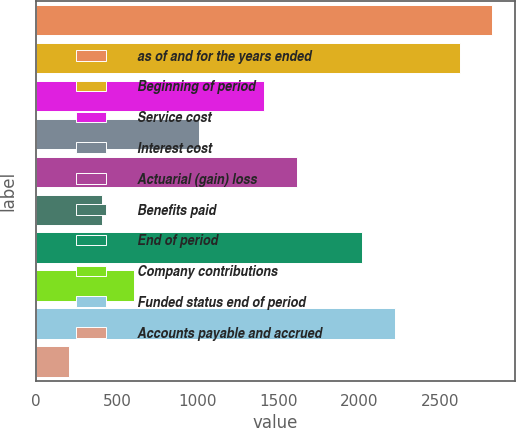Convert chart to OTSL. <chart><loc_0><loc_0><loc_500><loc_500><bar_chart><fcel>as of and for the years ended<fcel>Beginning of period<fcel>Service cost<fcel>Interest cost<fcel>Actuarial (gain) loss<fcel>Benefits paid<fcel>End of period<fcel>Company contributions<fcel>Funded status end of period<fcel>Accounts payable and accrued<nl><fcel>2824<fcel>2622.5<fcel>1413.5<fcel>1010.5<fcel>1615<fcel>406<fcel>2018<fcel>607.5<fcel>2219.5<fcel>204.5<nl></chart> 